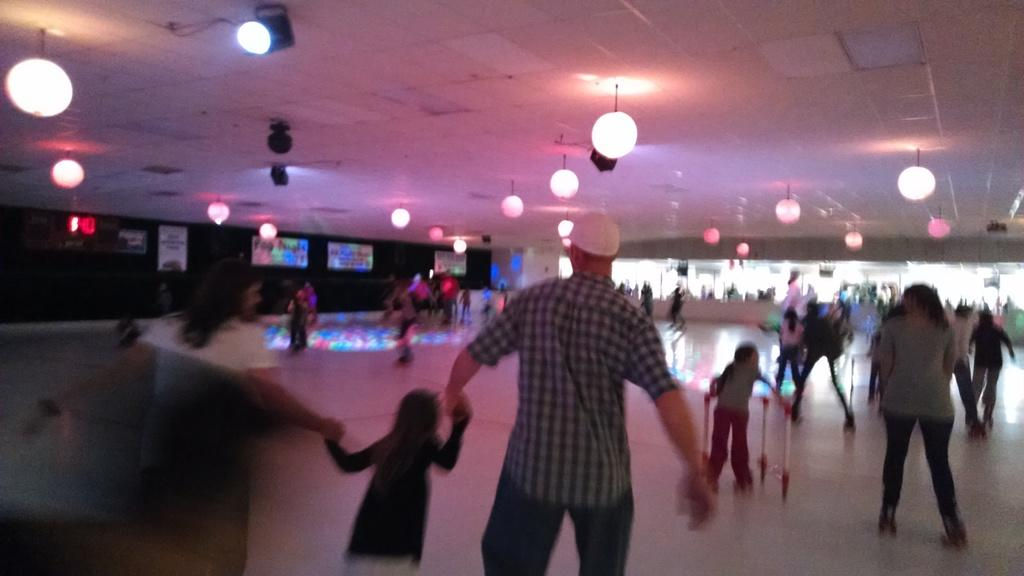What are the people in the image doing on the floor? There are persons on the floor in the image, but their specific activity is not mentioned in the facts. What can be seen attached to the roof in the image? Lights are attached to the roof in the image. Can you describe the interaction between a person and a kid in the image? There is a person holding the hand of a kid in the image. What type of straw is being used to reward the kid in the image? There is no straw or reward present in the image; it only shows persons on the floor and lights attached to the roof. How far is the person stretching to hold the hand of the kid in the image? The distance the person is stretching to hold the hand of the kid is not mentioned in the facts, and therefore cannot be determined. 